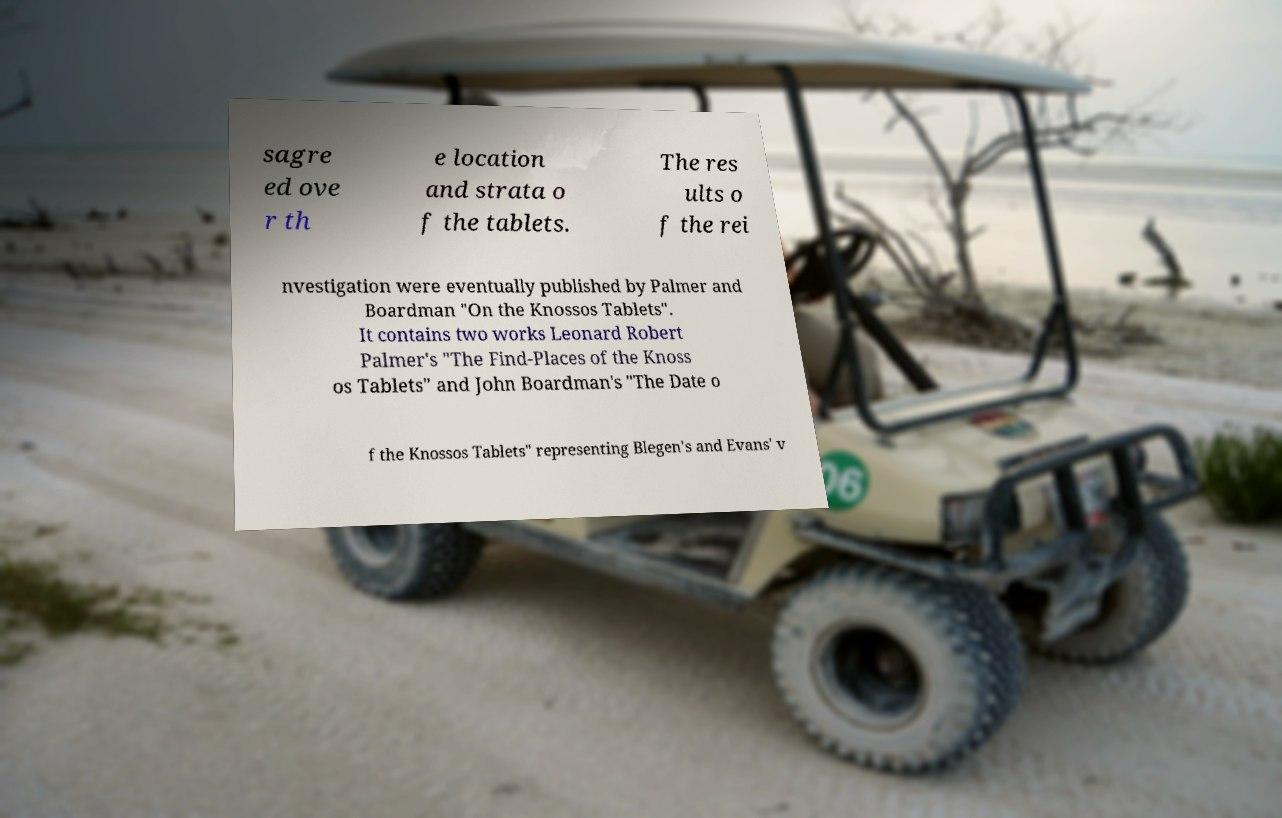Please identify and transcribe the text found in this image. sagre ed ove r th e location and strata o f the tablets. The res ults o f the rei nvestigation were eventually published by Palmer and Boardman "On the Knossos Tablets". It contains two works Leonard Robert Palmer's "The Find-Places of the Knoss os Tablets" and John Boardman's "The Date o f the Knossos Tablets" representing Blegen's and Evans' v 